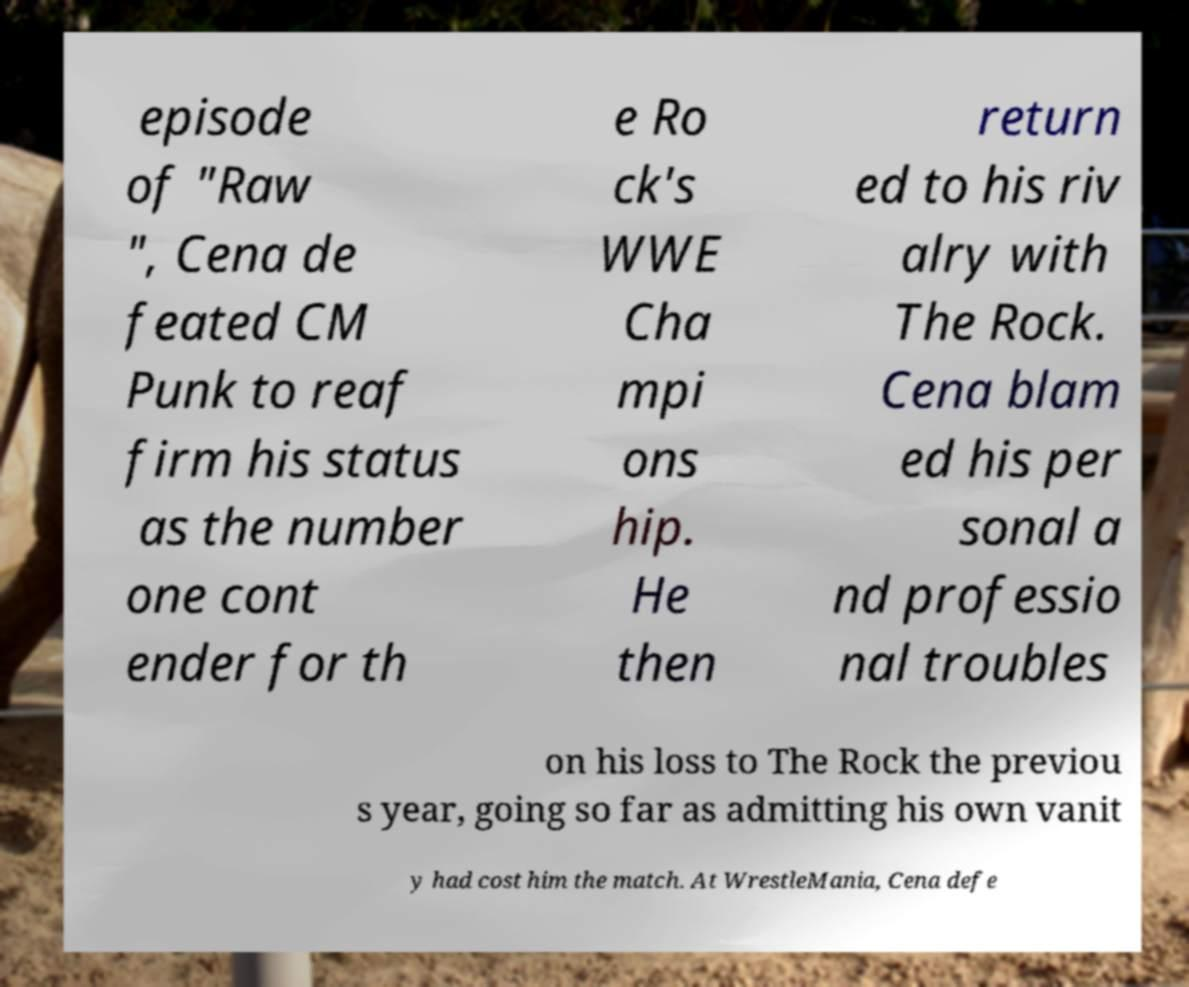For documentation purposes, I need the text within this image transcribed. Could you provide that? episode of "Raw ", Cena de feated CM Punk to reaf firm his status as the number one cont ender for th e Ro ck's WWE Cha mpi ons hip. He then return ed to his riv alry with The Rock. Cena blam ed his per sonal a nd professio nal troubles on his loss to The Rock the previou s year, going so far as admitting his own vanit y had cost him the match. At WrestleMania, Cena defe 